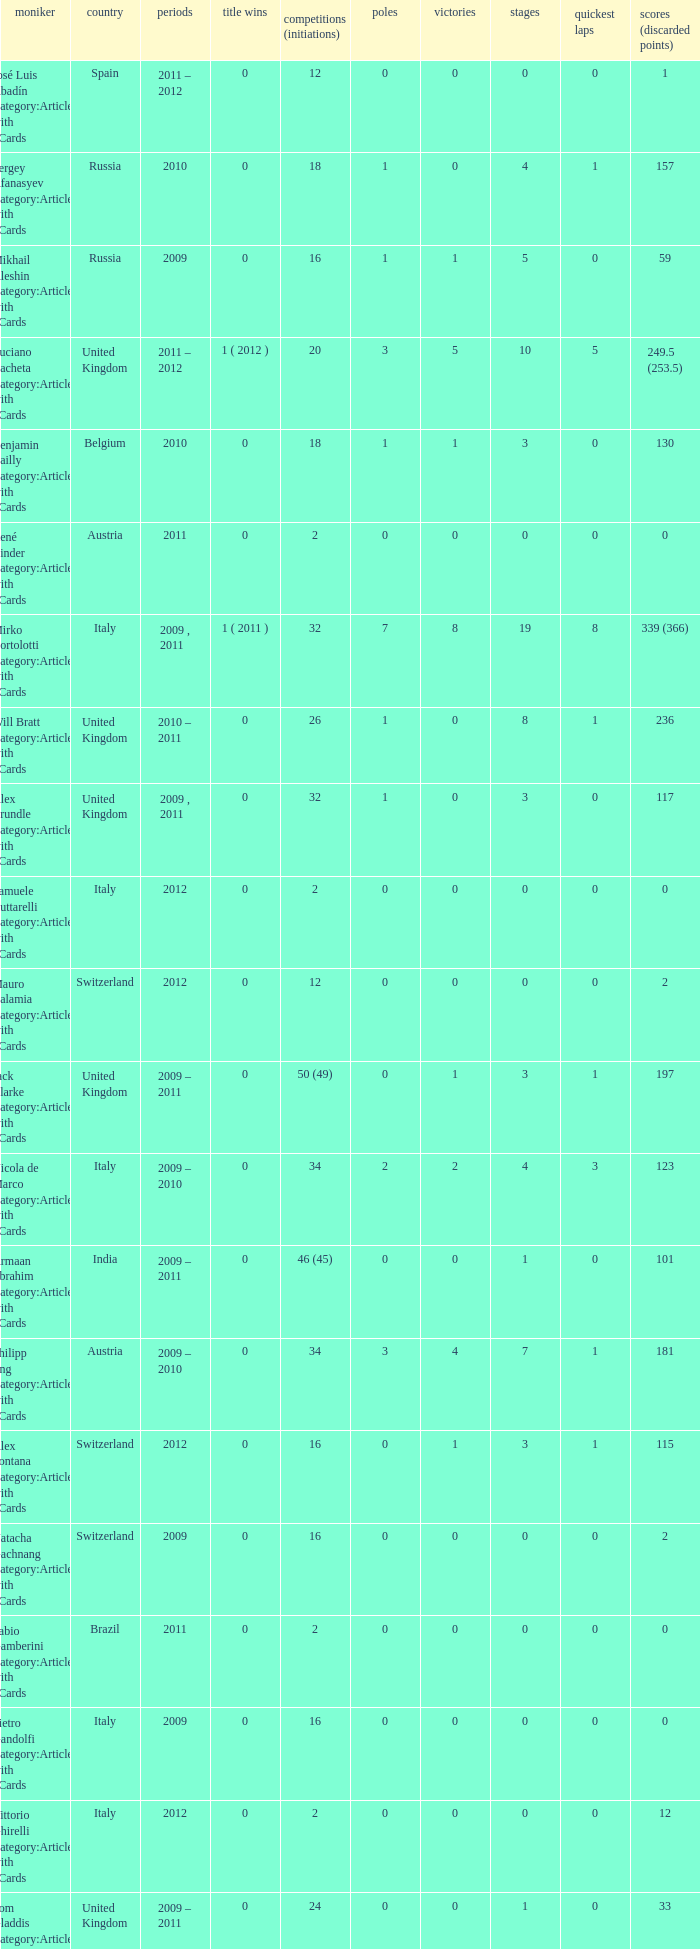What is the minimum amount of poles? 0.0. Parse the table in full. {'header': ['moniker', 'country', 'periods', 'title wins', 'competitions (initiations)', 'poles', 'victories', 'stages', 'quickest laps', 'scores (discarded points)'], 'rows': [['José Luis Abadín Category:Articles with hCards', 'Spain', '2011 – 2012', '0', '12', '0', '0', '0', '0', '1'], ['Sergey Afanasyev Category:Articles with hCards', 'Russia', '2010', '0', '18', '1', '0', '4', '1', '157'], ['Mikhail Aleshin Category:Articles with hCards', 'Russia', '2009', '0', '16', '1', '1', '5', '0', '59'], ['Luciano Bacheta Category:Articles with hCards', 'United Kingdom', '2011 – 2012', '1 ( 2012 )', '20', '3', '5', '10', '5', '249.5 (253.5)'], ['Benjamin Bailly Category:Articles with hCards', 'Belgium', '2010', '0', '18', '1', '1', '3', '0', '130'], ['René Binder Category:Articles with hCards', 'Austria', '2011', '0', '2', '0', '0', '0', '0', '0'], ['Mirko Bortolotti Category:Articles with hCards', 'Italy', '2009 , 2011', '1 ( 2011 )', '32', '7', '8', '19', '8', '339 (366)'], ['Will Bratt Category:Articles with hCards', 'United Kingdom', '2010 – 2011', '0', '26', '1', '0', '8', '1', '236'], ['Alex Brundle Category:Articles with hCards', 'United Kingdom', '2009 , 2011', '0', '32', '1', '0', '3', '0', '117'], ['Samuele Buttarelli Category:Articles with hCards', 'Italy', '2012', '0', '2', '0', '0', '0', '0', '0'], ['Mauro Calamia Category:Articles with hCards', 'Switzerland', '2012', '0', '12', '0', '0', '0', '0', '2'], ['Jack Clarke Category:Articles with hCards', 'United Kingdom', '2009 – 2011', '0', '50 (49)', '0', '1', '3', '1', '197'], ['Nicola de Marco Category:Articles with hCards', 'Italy', '2009 – 2010', '0', '34', '2', '2', '4', '3', '123'], ['Armaan Ebrahim Category:Articles with hCards', 'India', '2009 – 2011', '0', '46 (45)', '0', '0', '1', '0', '101'], ['Philipp Eng Category:Articles with hCards', 'Austria', '2009 – 2010', '0', '34', '3', '4', '7', '1', '181'], ['Alex Fontana Category:Articles with hCards', 'Switzerland', '2012', '0', '16', '0', '1', '3', '1', '115'], ['Natacha Gachnang Category:Articles with hCards', 'Switzerland', '2009', '0', '16', '0', '0', '0', '0', '2'], ['Fabio Gamberini Category:Articles with hCards', 'Brazil', '2011', '0', '2', '0', '0', '0', '0', '0'], ['Pietro Gandolfi Category:Articles with hCards', 'Italy', '2009', '0', '16', '0', '0', '0', '0', '0'], ['Vittorio Ghirelli Category:Articles with hCards', 'Italy', '2012', '0', '2', '0', '0', '0', '0', '12'], ['Tom Gladdis Category:Articles with hCards', 'United Kingdom', '2009 – 2011', '0', '24', '0', '0', '1', '0', '33'], ['Richard Gonda Category:Articles with hCards', 'Slovakia', '2012', '0', '2', '0', '0', '0', '0', '4'], ['Victor Guerin Category:Articles with hCards', 'Brazil', '2012', '0', '2', '0', '0', '0', '0', '2'], ['Ollie Hancock Category:Articles with hCards', 'United Kingdom', '2009', '0', '6', '0', '0', '0', '0', '0'], ['Tobias Hegewald Category:Articles with hCards', 'Germany', '2009 , 2011', '0', '32', '4', '2', '5', '3', '158'], ['Sebastian Hohenthal Category:Articles with hCards', 'Sweden', '2009', '0', '16', '0', '0', '0', '0', '7'], ['Jens Höing Category:Articles with hCards', 'Germany', '2009', '0', '16', '0', '0', '0', '0', '0'], ['Hector Hurst Category:Articles with hCards', 'United Kingdom', '2012', '0', '16', '0', '0', '0', '0', '27'], ['Carlos Iaconelli Category:Articles with hCards', 'Brazil', '2009', '0', '14', '0', '0', '1', '0', '21'], ['Axcil Jefferies Category:Articles with hCards', 'Zimbabwe', '2012', '0', '12 (11)', '0', '0', '0', '0', '17'], ['Johan Jokinen Category:Articles with hCards', 'Denmark', '2010', '0', '6', '0', '0', '1', '1', '21'], ['Julien Jousse Category:Articles with hCards', 'France', '2009', '0', '16', '1', '1', '4', '2', '49'], ['Henri Karjalainen Category:Articles with hCards', 'Finland', '2009', '0', '16', '0', '0', '0', '0', '7'], ['Kourosh Khani Category:Articles with hCards', 'Iran', '2012', '0', '8', '0', '0', '0', '0', '2'], ['Jordan King Category:Articles with hCards', 'United Kingdom', '2011', '0', '6', '0', '0', '0', '0', '17'], ['Natalia Kowalska Category:Articles with hCards', 'Poland', '2010 – 2011', '0', '20', '0', '0', '0', '0', '3'], ['Plamen Kralev Category:Articles with hCards', 'Bulgaria', '2010 – 2012', '0', '50 (49)', '0', '0', '0', '0', '6'], ['Ajith Kumar Category:Articles with hCards', 'India', '2010', '0', '6', '0', '0', '0', '0', '0'], ['Jon Lancaster Category:Articles with hCards', 'United Kingdom', '2011', '0', '2', '0', '0', '0', '0', '14'], ['Benjamin Lariche Category:Articles with hCards', 'France', '2010 – 2011', '0', '34', '0', '0', '0', '0', '48'], ['Mikkel Mac Category:Articles with hCards', 'Denmark', '2011', '0', '16', '0', '0', '0', '0', '23'], ['Mihai Marinescu Category:Articles with hCards', 'Romania', '2010 – 2012', '0', '50', '4', '3', '8', '4', '299'], ['Daniel McKenzie Category:Articles with hCards', 'United Kingdom', '2012', '0', '16', '0', '0', '2', '0', '95'], ['Kevin Mirocha Category:Articles with hCards', 'Poland', '2012', '0', '16', '1', '1', '6', '0', '159.5'], ['Miki Monrás Category:Articles with hCards', 'Spain', '2011', '0', '16', '1', '1', '4', '1', '153'], ['Jason Moore Category:Articles with hCards', 'United Kingdom', '2009', '0', '16 (15)', '0', '0', '0', '0', '3'], ['Sung-Hak Mun Category:Articles with hCards', 'South Korea', '2011', '0', '16 (15)', '0', '0', '0', '0', '0'], ['Jolyon Palmer Category:Articles with hCards', 'United Kingdom', '2009 – 2010', '0', '34 (36)', '5', '5', '10', '3', '245'], ['Miloš Pavlović Category:Articles with hCards', 'Serbia', '2009', '0', '16', '0', '0', '2', '1', '29'], ['Ramón Piñeiro Category:Articles with hCards', 'Spain', '2010 – 2011', '0', '18', '2', '3', '7', '2', '186'], ['Markus Pommer Category:Articles with hCards', 'Germany', '2012', '0', '16', '4', '3', '5', '2', '169'], ['Edoardo Piscopo Category:Articles with hCards', 'Italy', '2009', '0', '14', '0', '0', '0', '0', '19'], ['Paul Rees Category:Articles with hCards', 'United Kingdom', '2010', '0', '8', '0', '0', '0', '0', '18'], ['Ivan Samarin Category:Articles with hCards', 'Russia', '2010', '0', '18', '0', '0', '0', '0', '64'], ['Germán Sánchez Category:Articles with hCards', 'Spain', '2009', '0', '16 (14)', '0', '0', '0', '0', '2'], ['Harald Schlegelmilch Category:Articles with hCards', 'Latvia', '2012', '0', '2', '0', '0', '0', '0', '12'], ['Max Snegirev Category:Articles with hCards', 'Russia', '2011 – 2012', '0', '28', '0', '0', '0', '0', '20'], ['Kelvin Snoeks Category:Articles with hCards', 'Netherlands', '2010 – 2011', '0', '32', '0', '0', '1', '0', '88'], ['Andy Soucek Category:Articles with hCards', 'Spain', '2009', '1 ( 2009 )', '16', '2', '7', '11', '3', '115'], ['Dean Stoneman Category:Articles with hCards', 'United Kingdom', '2010', '1 ( 2010 )', '18', '6', '6', '13', '6', '284'], ['Thiemo Storz Category:Articles with hCards', 'Germany', '2011', '0', '16', '0', '0', '0', '0', '19'], ['Parthiva Sureshwaren Category:Articles with hCards', 'India', '2010 – 2012', '0', '32 (31)', '0', '0', '0', '0', '1'], ['Henry Surtees Category:Articles with hCards', 'United Kingdom', '2009', '0', '8', '1', '0', '1', '0', '8'], ['Ricardo Teixeira Category:Articles with hCards', 'Angola', '2010', '0', '18', '0', '0', '0', '0', '23'], ['Johannes Theobald Category:Articles with hCards', 'Germany', '2010 – 2011', '0', '14', '0', '0', '0', '0', '1'], ['Julian Theobald Category:Articles with hCards', 'Germany', '2010 – 2011', '0', '18', '0', '0', '0', '0', '8'], ['Mathéo Tuscher Category:Articles with hCards', 'Switzerland', '2012', '0', '16', '4', '2', '9', '1', '210'], ['Tristan Vautier Category:Articles with hCards', 'France', '2009', '0', '2', '0', '0', '1', '0', '9'], ['Kazim Vasiliauskas Category:Articles with hCards', 'Lithuania', '2009 – 2010', '0', '34', '3', '2', '10', '4', '198'], ['Robert Wickens Category:Articles with hCards', 'Canada', '2009', '0', '16', '5', '2', '6', '3', '64'], ['Dino Zamparelli Category:Articles with hCards', 'United Kingdom', '2012', '0', '16', '0', '0', '2', '0', '106.5'], ['Christopher Zanella Category:Articles with hCards', 'Switzerland', '2011 – 2012', '0', '32', '3', '4', '14', '5', '385 (401)']]} 